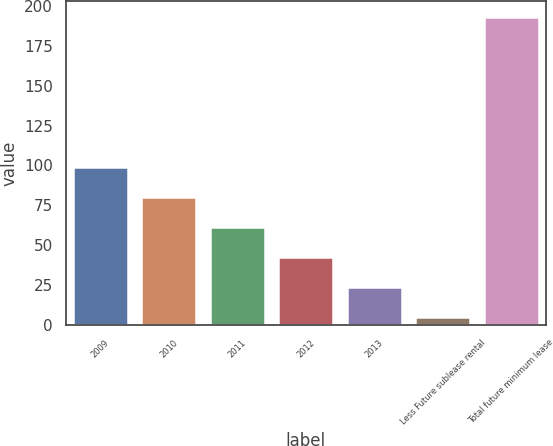Convert chart. <chart><loc_0><loc_0><loc_500><loc_500><bar_chart><fcel>2009<fcel>2010<fcel>2011<fcel>2012<fcel>2013<fcel>Less Future sublease rental<fcel>Total future minimum lease<nl><fcel>99.25<fcel>80.42<fcel>61.59<fcel>42.76<fcel>23.93<fcel>5.1<fcel>193.4<nl></chart> 